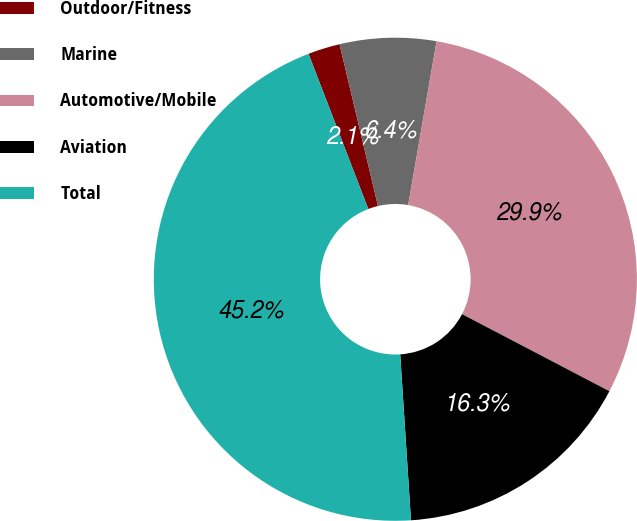<chart> <loc_0><loc_0><loc_500><loc_500><pie_chart><fcel>Outdoor/Fitness<fcel>Marine<fcel>Automotive/Mobile<fcel>Aviation<fcel>Total<nl><fcel>2.14%<fcel>6.44%<fcel>29.94%<fcel>16.3%<fcel>45.18%<nl></chart> 